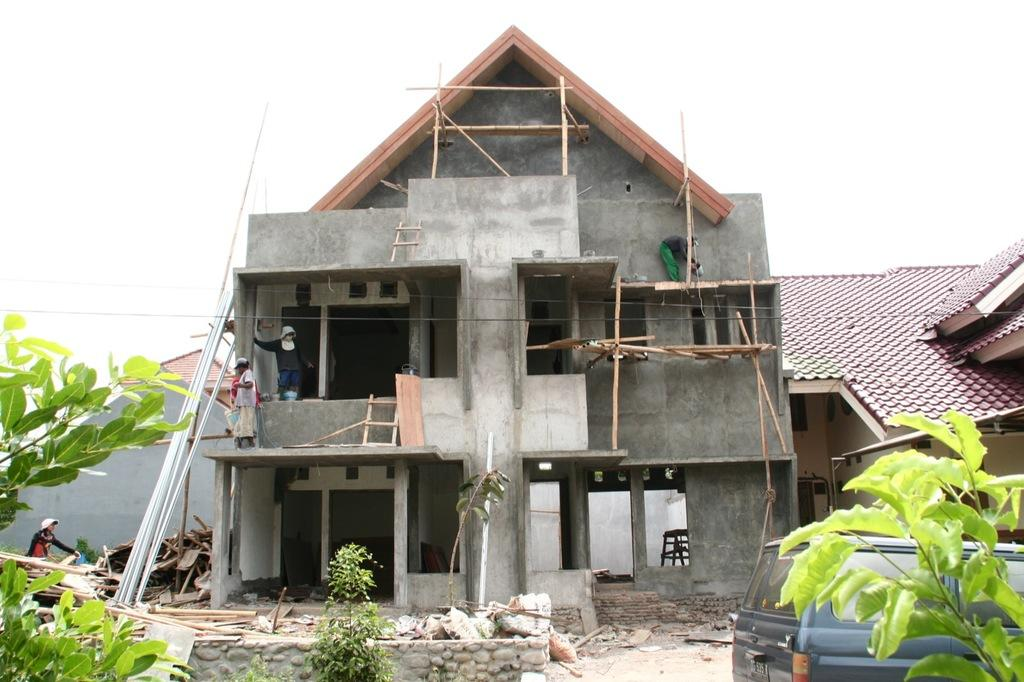What type of structures can be seen in the image? There are buildings in the image. What other elements are present in the image besides buildings? There are plants, a vehicle, people, wooden logs, and other objects in the image. Can you describe the natural elements in the image? There are plants and wooden logs in the image. What is visible in the sky in the image? The sky is visible in the image. How does the ant react to the comparison between the buildings in the image? There is no ant present in the image, so it cannot react to any comparison between the buildings. 